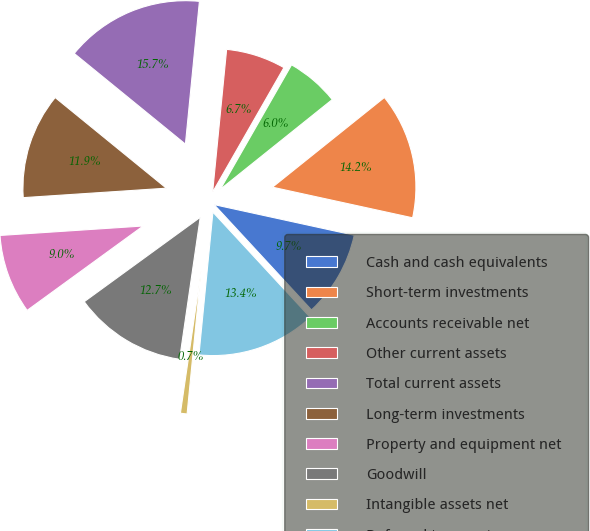Convert chart. <chart><loc_0><loc_0><loc_500><loc_500><pie_chart><fcel>Cash and cash equivalents<fcel>Short-term investments<fcel>Accounts receivable net<fcel>Other current assets<fcel>Total current assets<fcel>Long-term investments<fcel>Property and equipment net<fcel>Goodwill<fcel>Intangible assets net<fcel>Deferred tax assets<nl><fcel>9.7%<fcel>14.18%<fcel>5.97%<fcel>6.72%<fcel>15.67%<fcel>11.94%<fcel>8.96%<fcel>12.69%<fcel>0.75%<fcel>13.43%<nl></chart> 